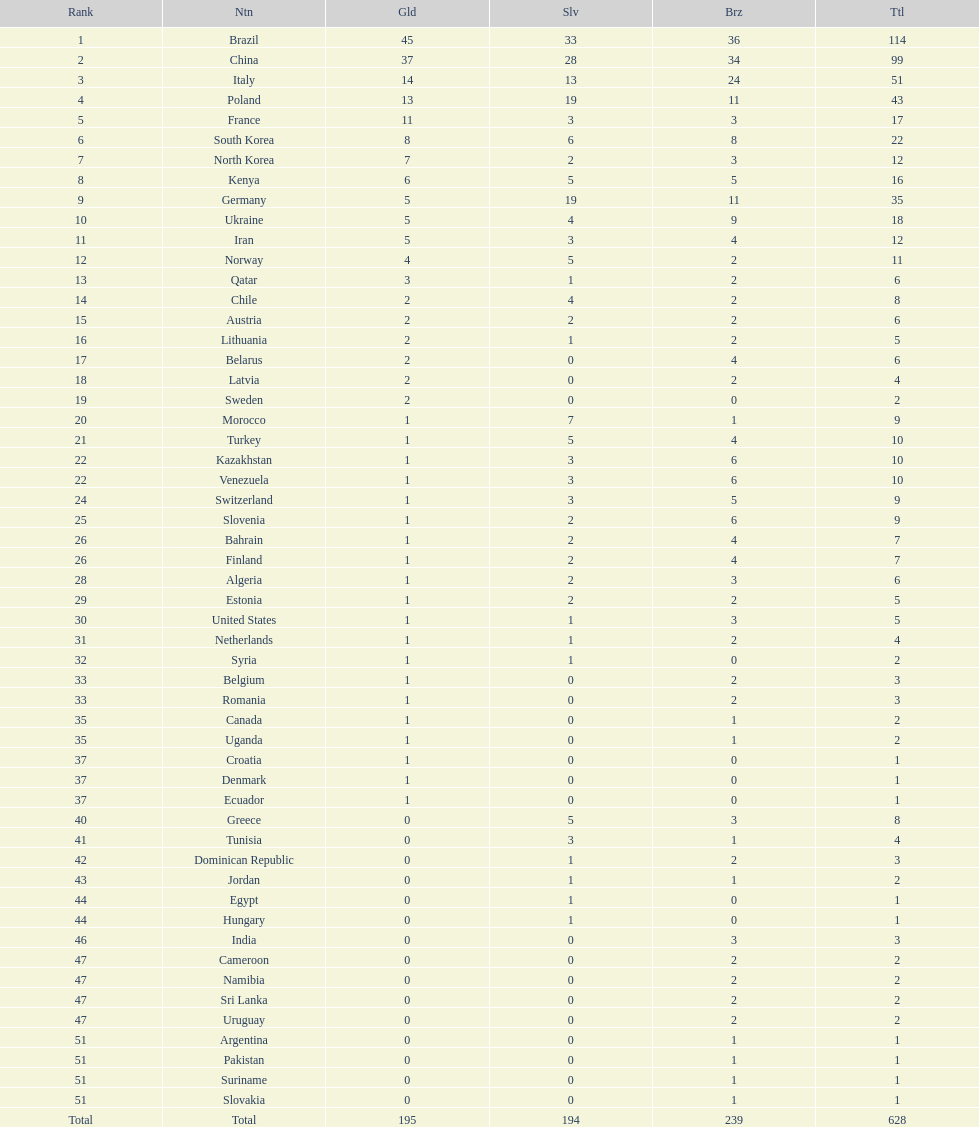Which nation earned the most gold medals? Brazil. 